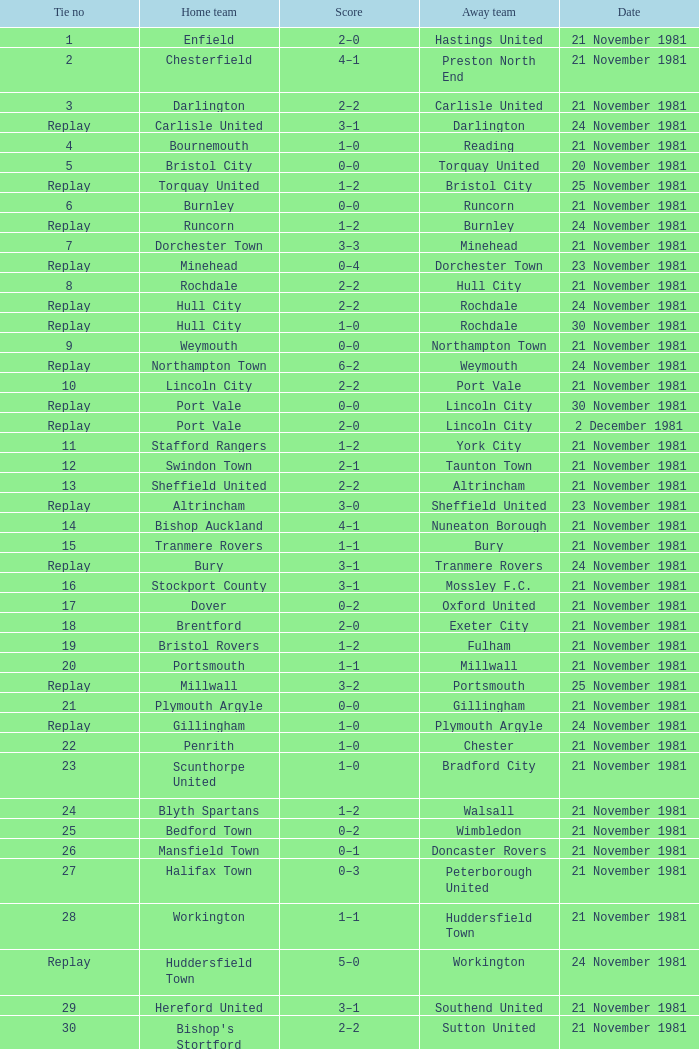What number corresponds to enfield's tie? 1.0. 